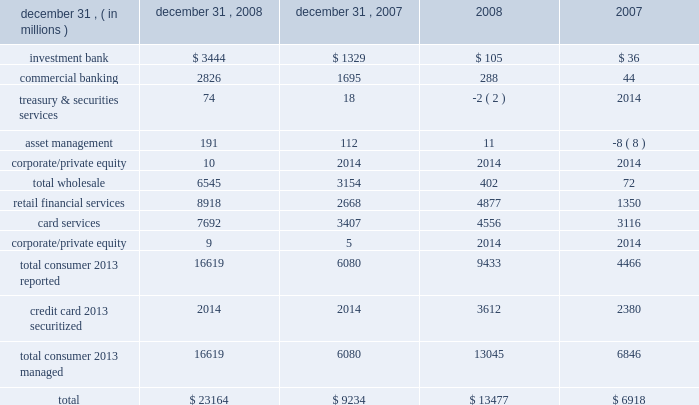Management 2019s discussion and analysis 110 jpmorgan chase & co .
/ 2008 annual report the allowance for credit losses increased $ 13.7 billion from the prior year to $ 23.8 billion .
The increase included $ 4.1 billion of allowance related to noncredit-impaired loans acquired in the washington mutual transaction and the related accounting conformity provision .
Excluding held-for-sale loans , loans carried at fair value , and pur- chased credit-impaired consumer loans , the allowance for loan losses represented 3.62% ( 3.62 % ) of loans at december 31 , 2008 , compared with 1.88% ( 1.88 % ) at december 31 , 2007 .
The consumer allowance for loan losses increased $ 10.5 billion from the prior year as a result of the washington mutual transaction and increased allowance for loan loss in residential real estate and credit card .
The increase included additions to the allowance for loan losses of $ 4.7 billion driven by higher estimated losses for residential mort- gage and home equity loans as the weak labor market and weak overall economic conditions have resulted in increased delinquencies , while continued weak housing prices have driven a significant increase in loss severity .
The allowance for loan losses related to credit card increased $ 4.3 billion from the prior year primarily due to the acquired allowance and subsequent conforming provision for loan loss related to the washington mutual bank acquisition and an increase in provision for loan losses of $ 2.3 billion in 2008 over 2007 , as higher estimated net charge-offs are expected in the port- folio resulting from the current economic conditions .
The wholesale allowance for loan losses increase of $ 3.4 billion from december 31 , 2007 , reflected the effect of a weakening credit envi- ronment and the transfer of $ 4.9 billion of funded and unfunded leveraged lending commitments to retained loans from held-for-sale .
To provide for the risk of loss inherent in the firm 2019s process of extending credit , an allowance for lending-related commitments is held for both wholesale and consumer , which is reported in other lia- bilities .
The wholesale component is computed using a methodology similar to that used for the wholesale loan portfolio , modified for expected maturities and probabilities of drawdown and has an asset- specific component and a formula-based component .
For a further discussion on the allowance for lending-related commitment see note 15 on pages 178 2013180 of this annual report .
The allowance for lending-related commitments for both wholesale and consumer was $ 659 million and $ 850 million at december 31 , 2008 and 2007 , respectively .
The decrease reflects the reduction in lending-related commitments at december 31 , 2008 .
For more information , see page 102 of this annual report .
The table presents the allowance for loan losses and net charge-offs ( recoveries ) by business segment at december 31 , 2008 and 2007 .
Net charge-offs ( recoveries ) december 31 , allowance for loan losses year ended .

What was the percentage change in net charge-offs relating to retail financial services between 2007 and 2008? 
Computations: ((8918 - 2668) / 2668)
Answer: 2.34258. 